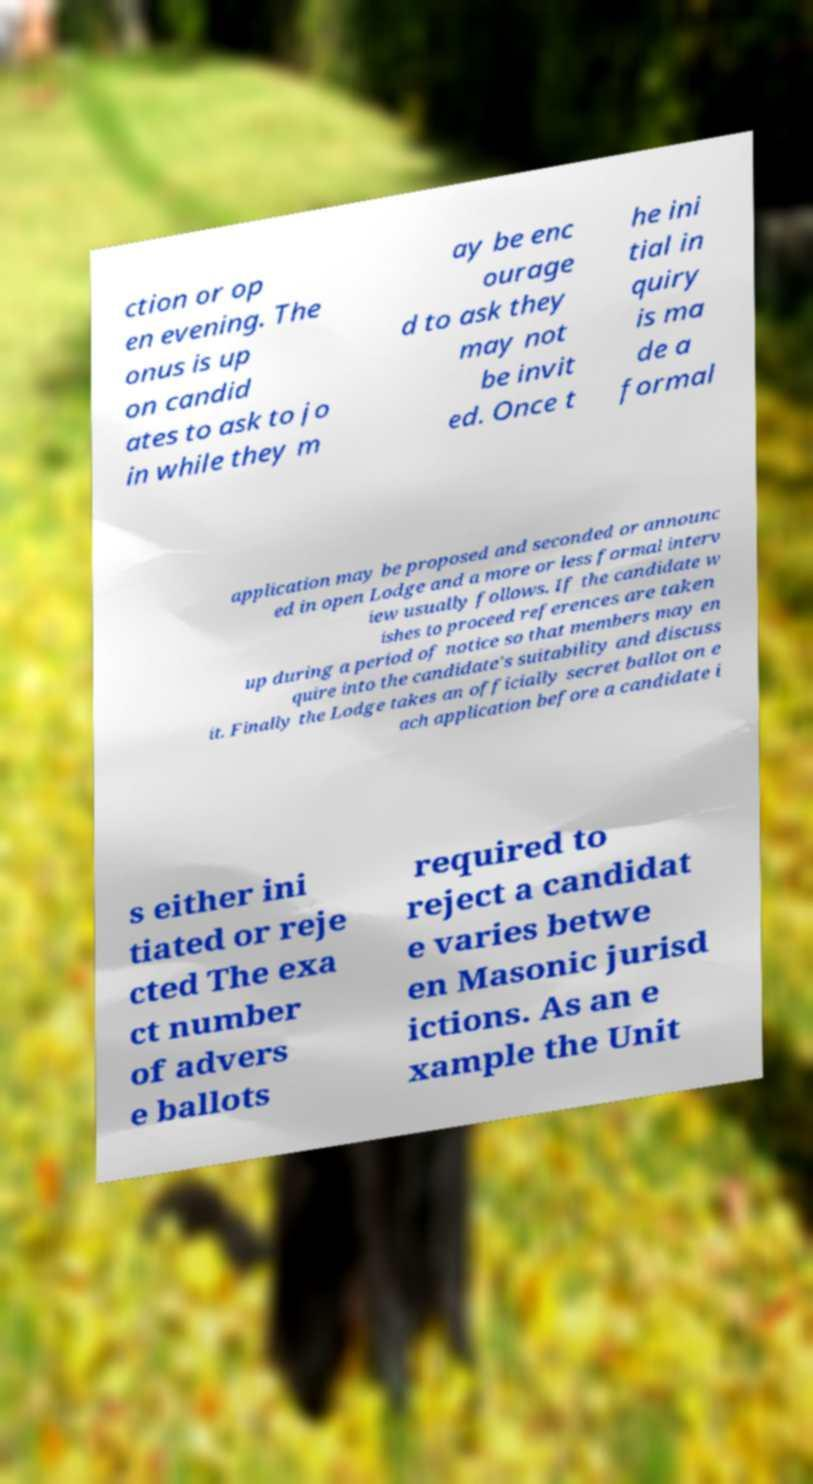Can you read and provide the text displayed in the image?This photo seems to have some interesting text. Can you extract and type it out for me? ction or op en evening. The onus is up on candid ates to ask to jo in while they m ay be enc ourage d to ask they may not be invit ed. Once t he ini tial in quiry is ma de a formal application may be proposed and seconded or announc ed in open Lodge and a more or less formal interv iew usually follows. If the candidate w ishes to proceed references are taken up during a period of notice so that members may en quire into the candidate's suitability and discuss it. Finally the Lodge takes an officially secret ballot on e ach application before a candidate i s either ini tiated or reje cted The exa ct number of advers e ballots required to reject a candidat e varies betwe en Masonic jurisd ictions. As an e xample the Unit 